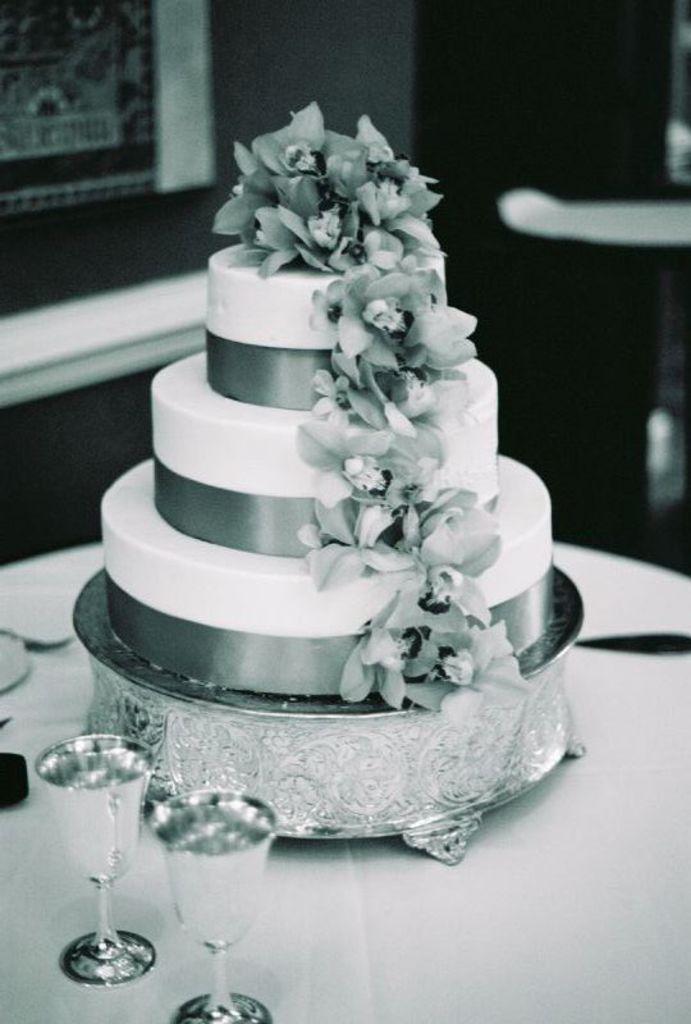How would you summarize this image in a sentence or two? In this image I can see the cake. To the side I can see the glasses. These are on the table. And there is a blurred background. This is a black and white image. 